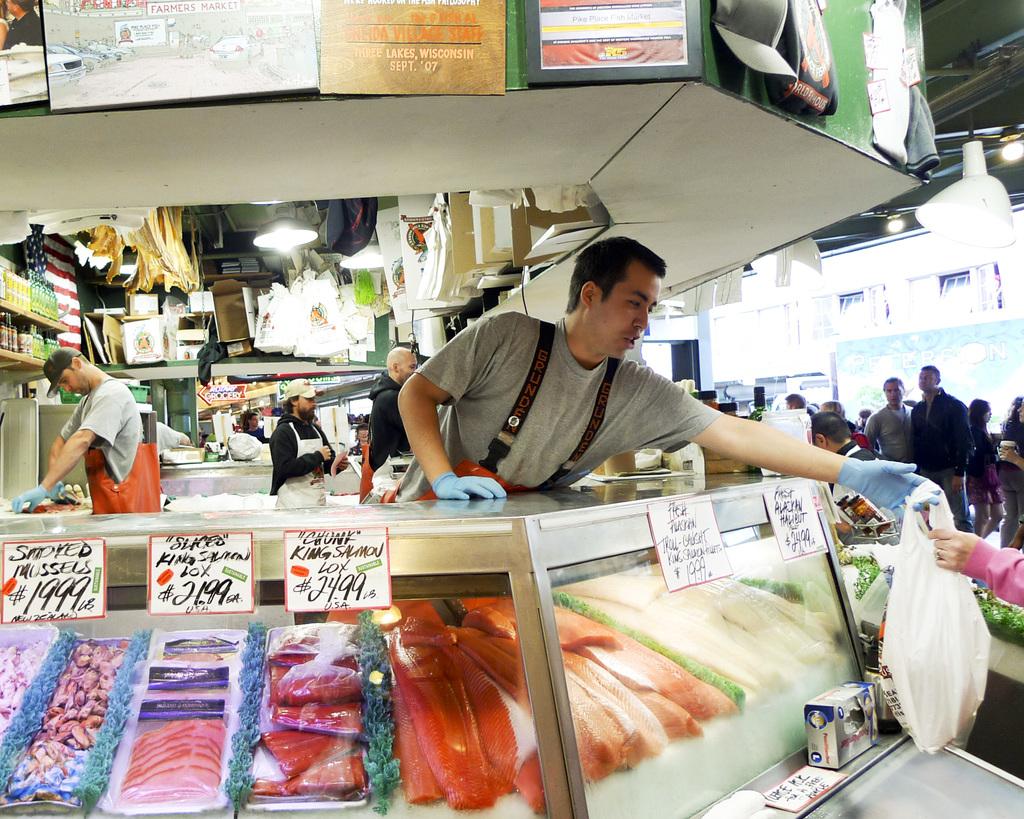What is being sold on the bottom left?
Your answer should be very brief. Smoked mussels. What kind of fish is being sold for $24.99/?
Provide a succinct answer. King salmon. 